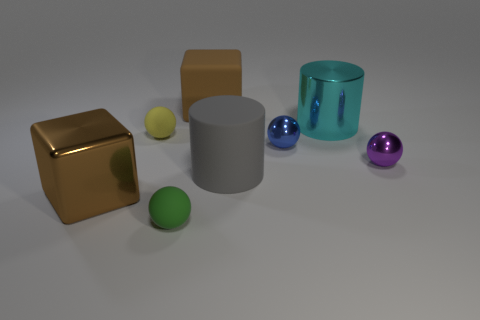What is the texture of the large cube? The large cube has a matte texture, exhibiting a non-glossy and non-reflective surface when compared to the shiny sphere-like objects and the cylindrical glass. 